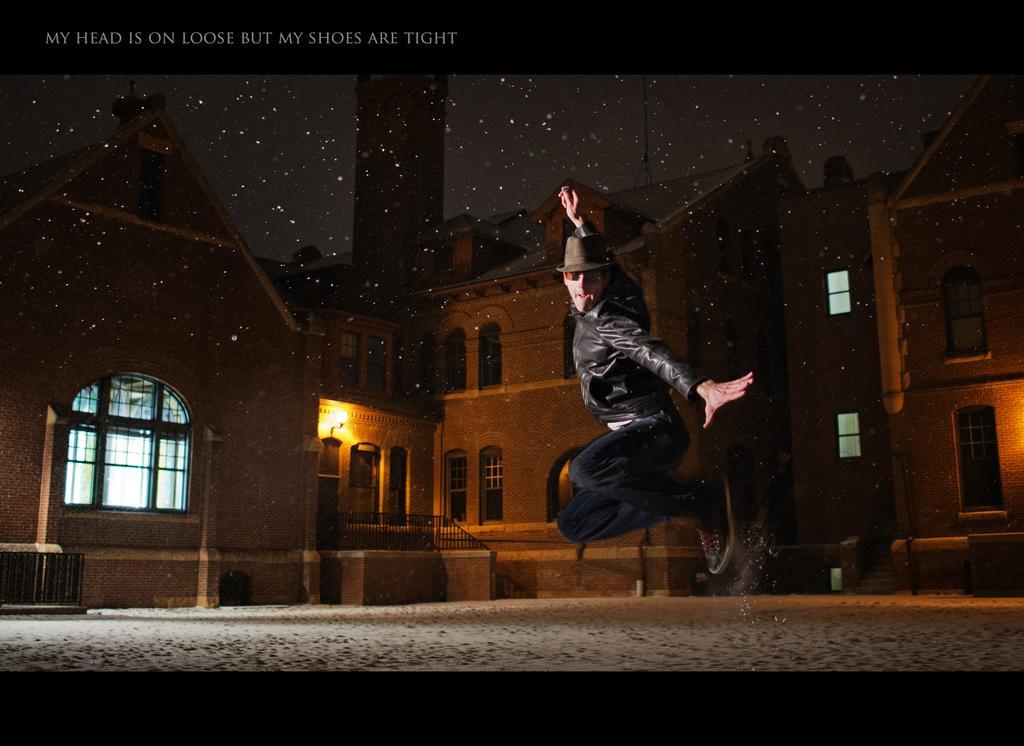Could you give a brief overview of what you see in this image? In this picture we can see a person is in the air and in the background we can see buildings and some objects, in the top left we can see some text on it. 